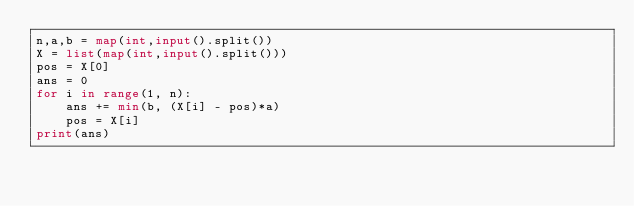Convert code to text. <code><loc_0><loc_0><loc_500><loc_500><_Python_>n,a,b = map(int,input().split())
X = list(map(int,input().split()))
pos = X[0]
ans = 0
for i in range(1, n):
    ans += min(b, (X[i] - pos)*a)
    pos = X[i]
print(ans)</code> 